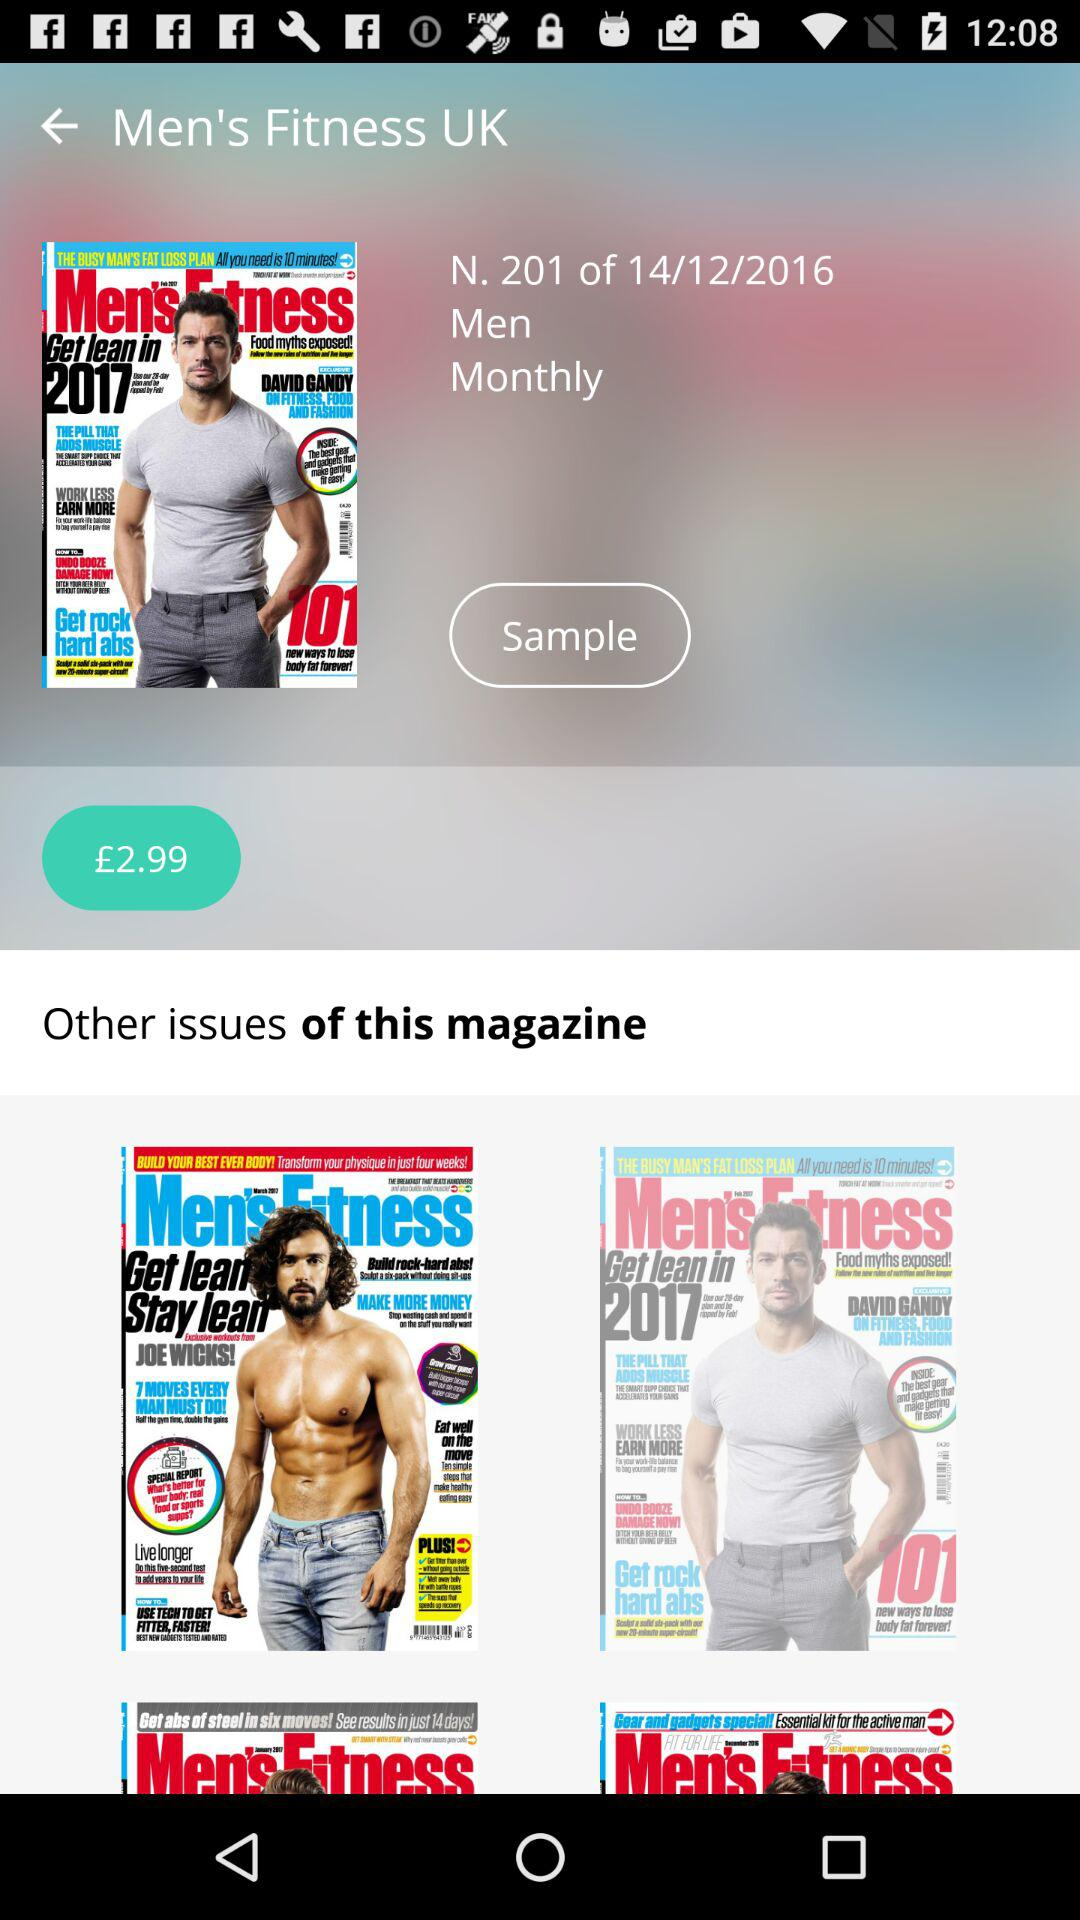What is the date of "N. 201" magazine? The date of "N. 201" magazine is December 14, 2016. 